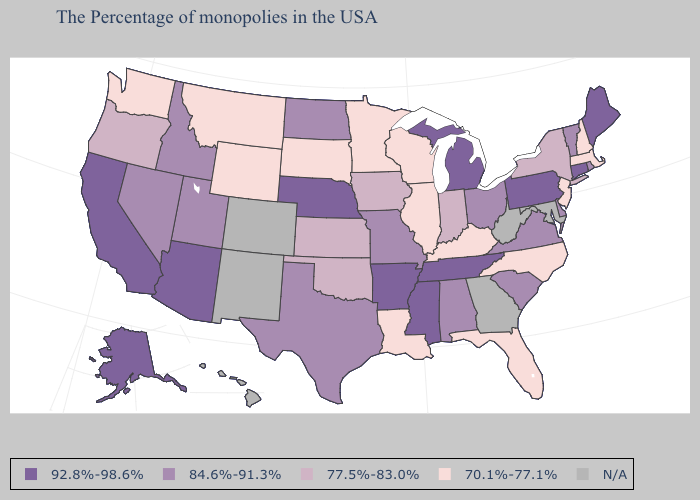Does Washington have the highest value in the West?
Give a very brief answer. No. Name the states that have a value in the range 84.6%-91.3%?
Concise answer only. Rhode Island, Vermont, Delaware, Virginia, South Carolina, Ohio, Alabama, Missouri, Texas, North Dakota, Utah, Idaho, Nevada. Name the states that have a value in the range N/A?
Quick response, please. Maryland, West Virginia, Georgia, Colorado, New Mexico, Hawaii. What is the highest value in states that border Delaware?
Concise answer only. 92.8%-98.6%. Name the states that have a value in the range N/A?
Give a very brief answer. Maryland, West Virginia, Georgia, Colorado, New Mexico, Hawaii. What is the value of New York?
Concise answer only. 77.5%-83.0%. What is the value of Connecticut?
Short answer required. 92.8%-98.6%. What is the value of Vermont?
Short answer required. 84.6%-91.3%. Among the states that border Illinois , does Kentucky have the highest value?
Answer briefly. No. What is the value of South Carolina?
Keep it brief. 84.6%-91.3%. Among the states that border Delaware , which have the highest value?
Short answer required. Pennsylvania. Which states hav the highest value in the Northeast?
Keep it brief. Maine, Connecticut, Pennsylvania. Among the states that border Wyoming , does South Dakota have the highest value?
Quick response, please. No. 